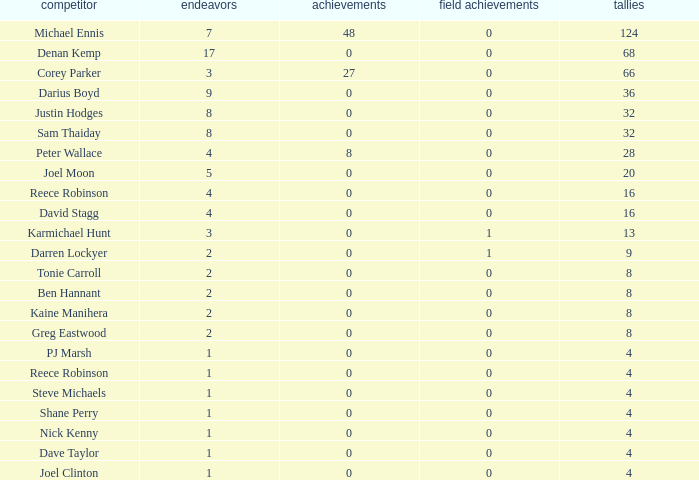How many goals did the player with less than 4 points have? 0.0. 